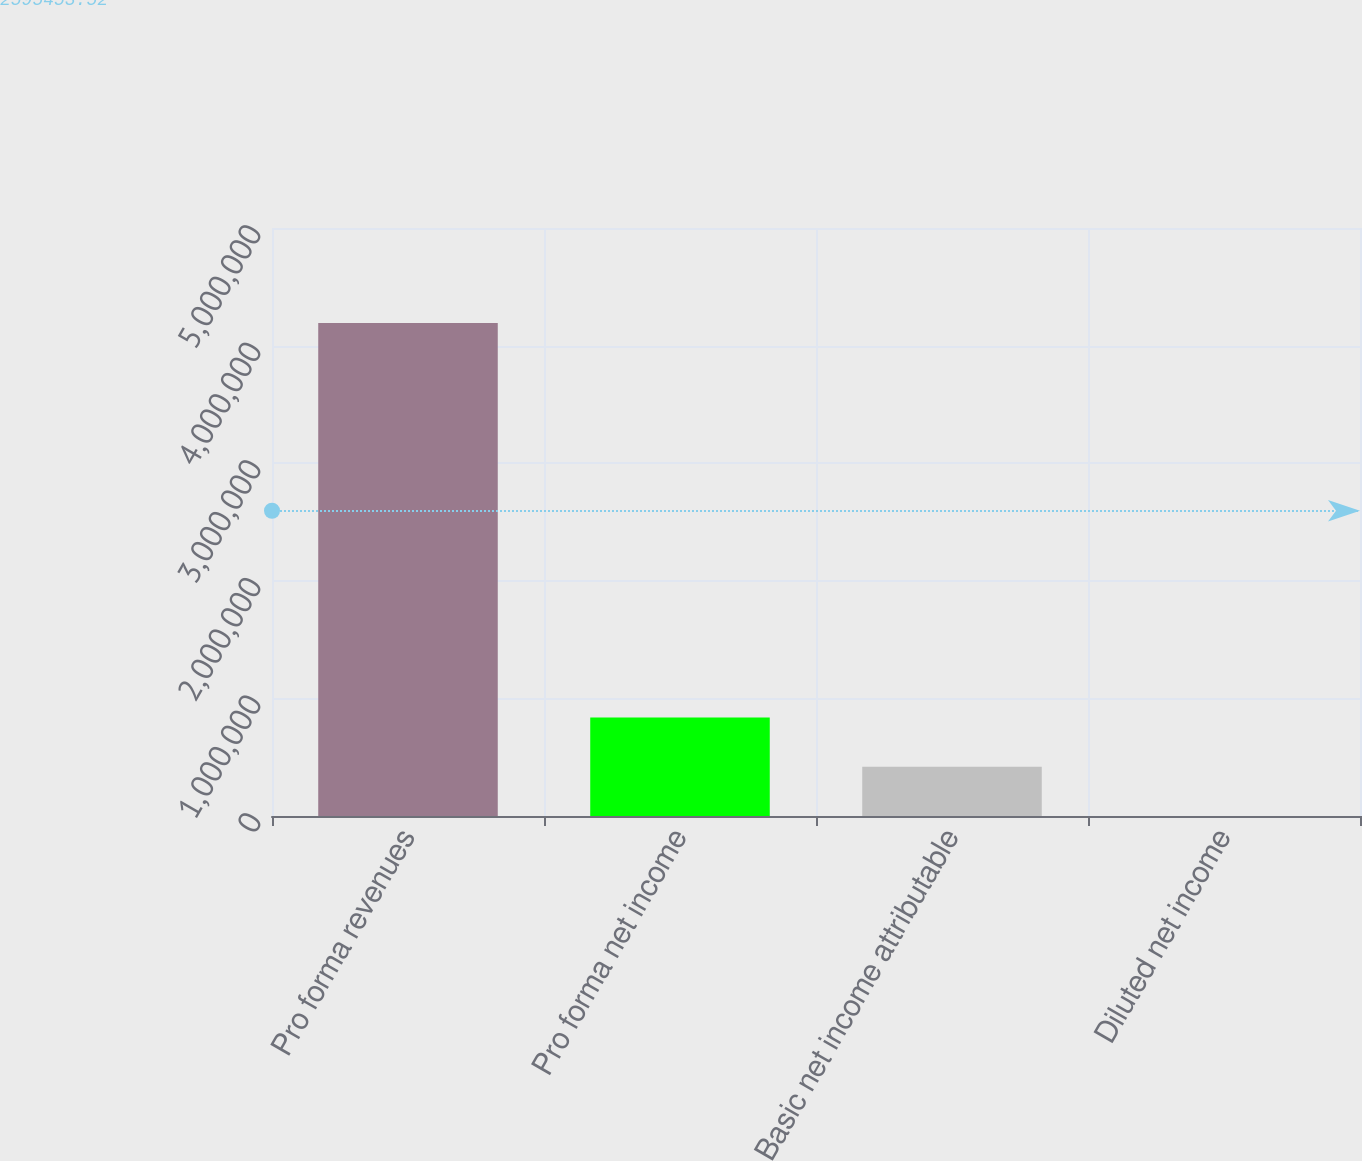Convert chart to OTSL. <chart><loc_0><loc_0><loc_500><loc_500><bar_chart><fcel>Pro forma revenues<fcel>Pro forma net income<fcel>Basic net income attributable<fcel>Diluted net income<nl><fcel>4.19307e+06<fcel>838615<fcel>419308<fcel>1.93<nl></chart> 